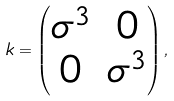Convert formula to latex. <formula><loc_0><loc_0><loc_500><loc_500>k = \begin{pmatrix} \sigma ^ { 3 } & 0 \\ 0 & \sigma ^ { 3 } \end{pmatrix} ,</formula> 